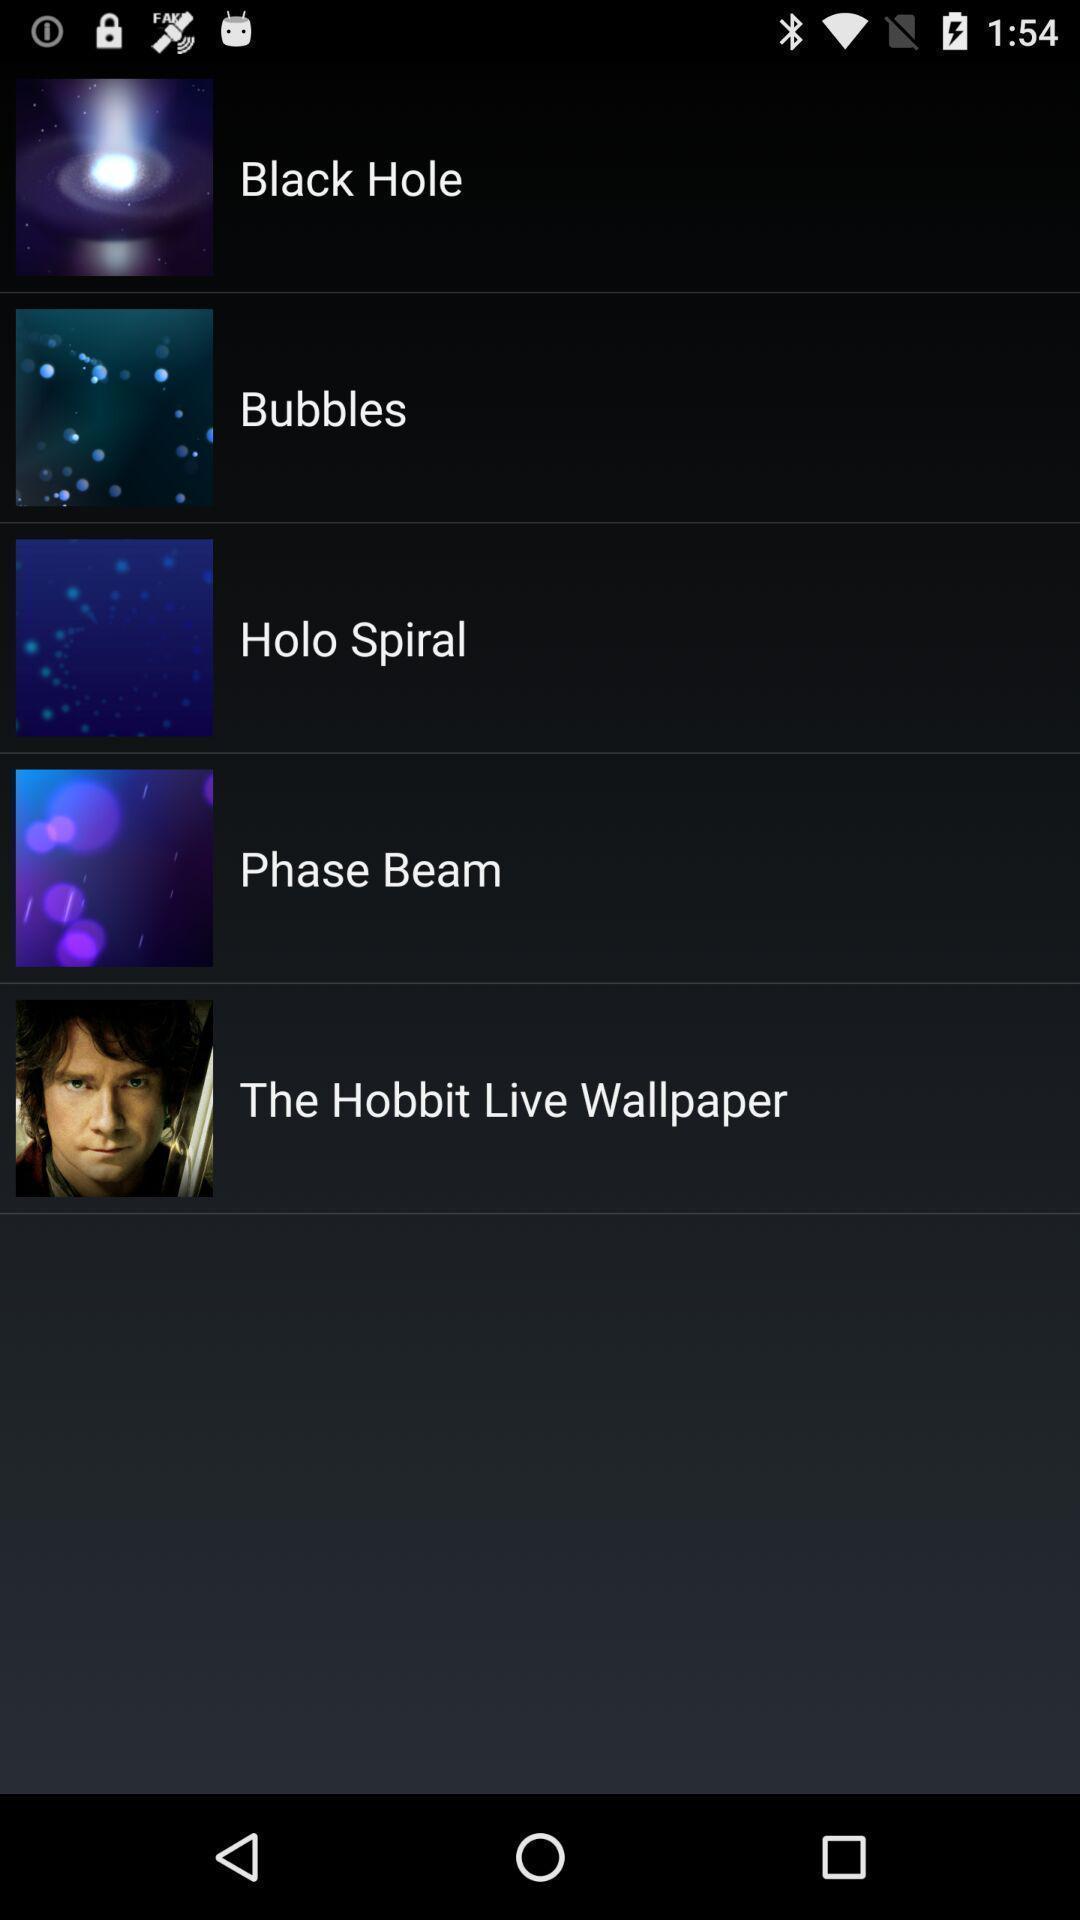Give me a summary of this screen capture. Various options displayed for a wallpaper app. 